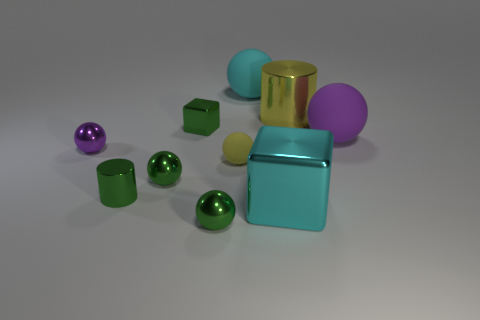How many shiny spheres are the same color as the small block?
Keep it short and to the point. 2. How many large objects are red cubes or green shiny cubes?
Ensure brevity in your answer.  0. The sphere that is the same color as the large cylinder is what size?
Give a very brief answer. Small. Is there a gray cylinder that has the same material as the small cube?
Your answer should be compact. No. There is a cyan object that is behind the big yellow thing; what material is it?
Offer a terse response. Rubber. Is the color of the shiny ball to the left of the green metallic cylinder the same as the shiny cylinder in front of the tiny green shiny block?
Ensure brevity in your answer.  No. What is the color of the other metallic thing that is the same size as the cyan metallic object?
Provide a succinct answer. Yellow. What number of other objects are there of the same shape as the tiny rubber thing?
Ensure brevity in your answer.  5. There is a rubber ball to the right of the yellow cylinder; how big is it?
Your response must be concise. Large. There is a large matte thing in front of the cyan matte sphere; how many tiny purple metallic things are right of it?
Keep it short and to the point. 0. 